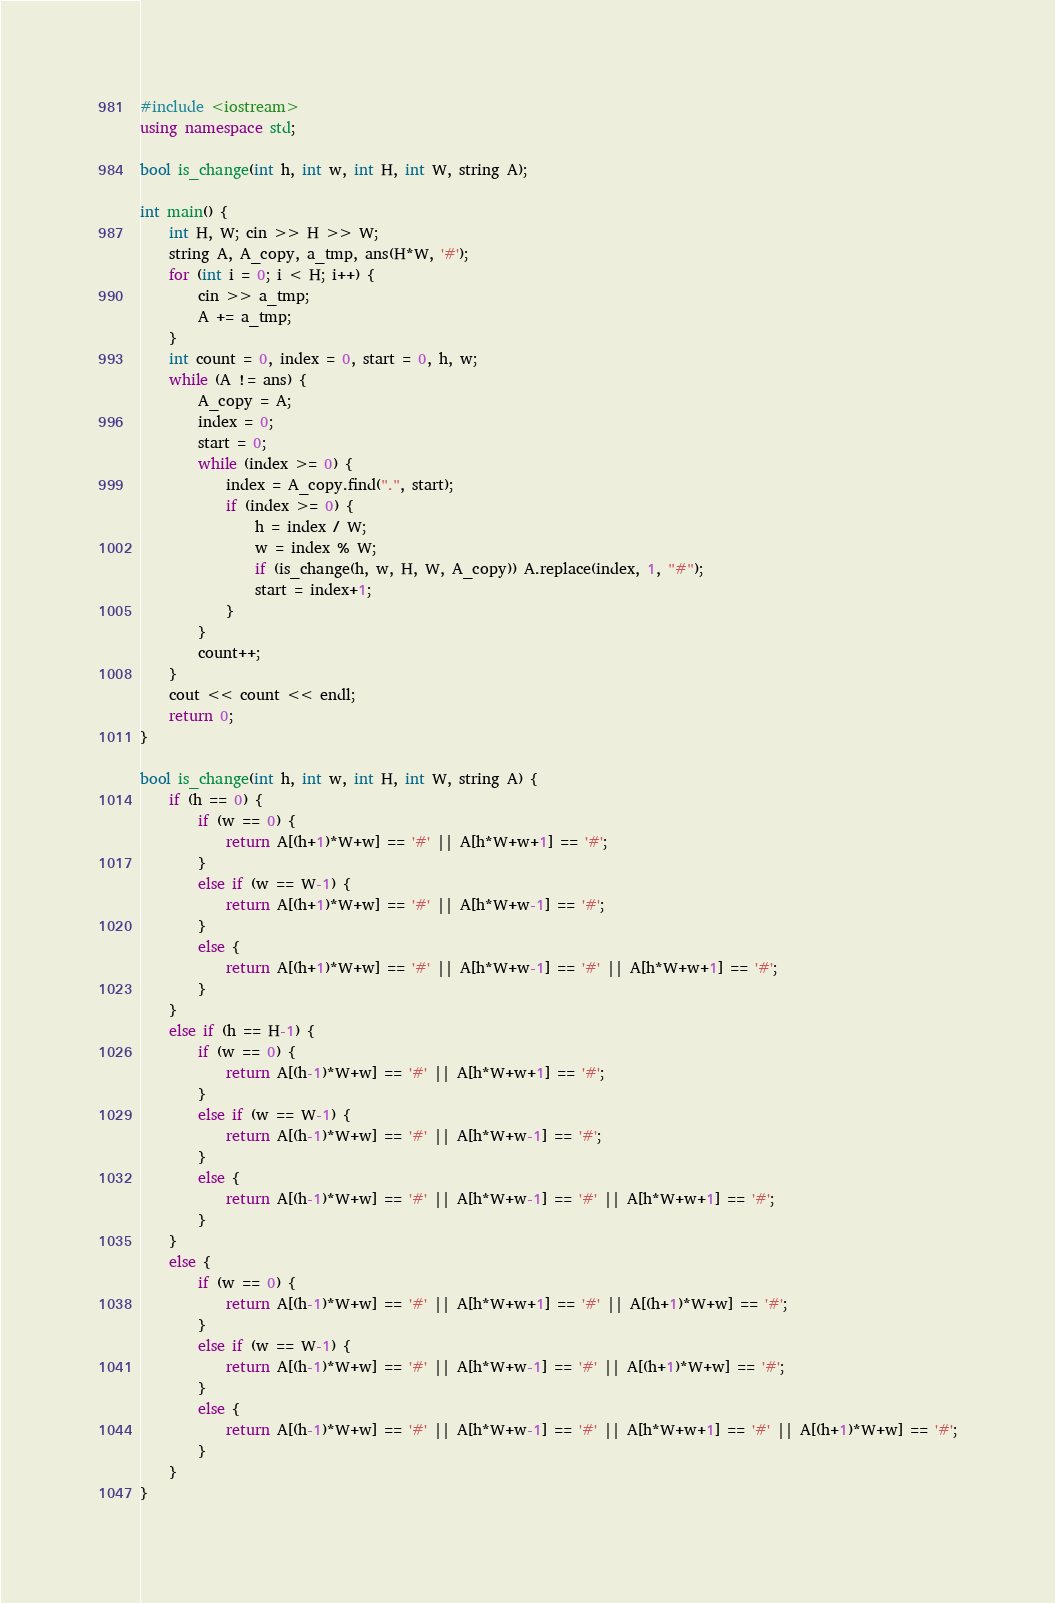<code> <loc_0><loc_0><loc_500><loc_500><_C++_>#include <iostream>
using namespace std;

bool is_change(int h, int w, int H, int W, string A);

int main() {
    int H, W; cin >> H >> W;
    string A, A_copy, a_tmp, ans(H*W, '#');
    for (int i = 0; i < H; i++) {
        cin >> a_tmp;
        A += a_tmp;
    }
    int count = 0, index = 0, start = 0, h, w;
    while (A != ans) {
        A_copy = A;
        index = 0;
        start = 0;
        while (index >= 0) {
            index = A_copy.find(".", start);
            if (index >= 0) {
                h = index / W;
                w = index % W;
                if (is_change(h, w, H, W, A_copy)) A.replace(index, 1, "#");
                start = index+1;
            }
        }
        count++;
    }
    cout << count << endl;
    return 0;
}

bool is_change(int h, int w, int H, int W, string A) {
    if (h == 0) {
        if (w == 0) {
            return A[(h+1)*W+w] == '#' || A[h*W+w+1] == '#';
        }
        else if (w == W-1) {
            return A[(h+1)*W+w] == '#' || A[h*W+w-1] == '#';
        }
        else {
            return A[(h+1)*W+w] == '#' || A[h*W+w-1] == '#' || A[h*W+w+1] == '#';
        }
    }
    else if (h == H-1) {
        if (w == 0) {
            return A[(h-1)*W+w] == '#' || A[h*W+w+1] == '#';
        }
        else if (w == W-1) {
            return A[(h-1)*W+w] == '#' || A[h*W+w-1] == '#';
        }
        else {
            return A[(h-1)*W+w] == '#' || A[h*W+w-1] == '#' || A[h*W+w+1] == '#';
        }
    }
    else {
        if (w == 0) {
            return A[(h-1)*W+w] == '#' || A[h*W+w+1] == '#' || A[(h+1)*W+w] == '#';
        }
        else if (w == W-1) {
            return A[(h-1)*W+w] == '#' || A[h*W+w-1] == '#' || A[(h+1)*W+w] == '#';
        }
        else {
            return A[(h-1)*W+w] == '#' || A[h*W+w-1] == '#' || A[h*W+w+1] == '#' || A[(h+1)*W+w] == '#';
        }
    }
}
</code> 